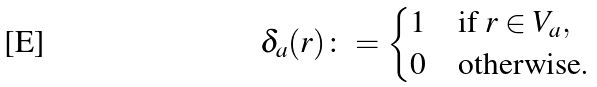Convert formula to latex. <formula><loc_0><loc_0><loc_500><loc_500>\delta _ { a } ( r ) \colon = \begin{cases} 1 & \text {if\ } r \in V _ { a } , \\ 0 & \text {otherwise} . \end{cases}</formula> 